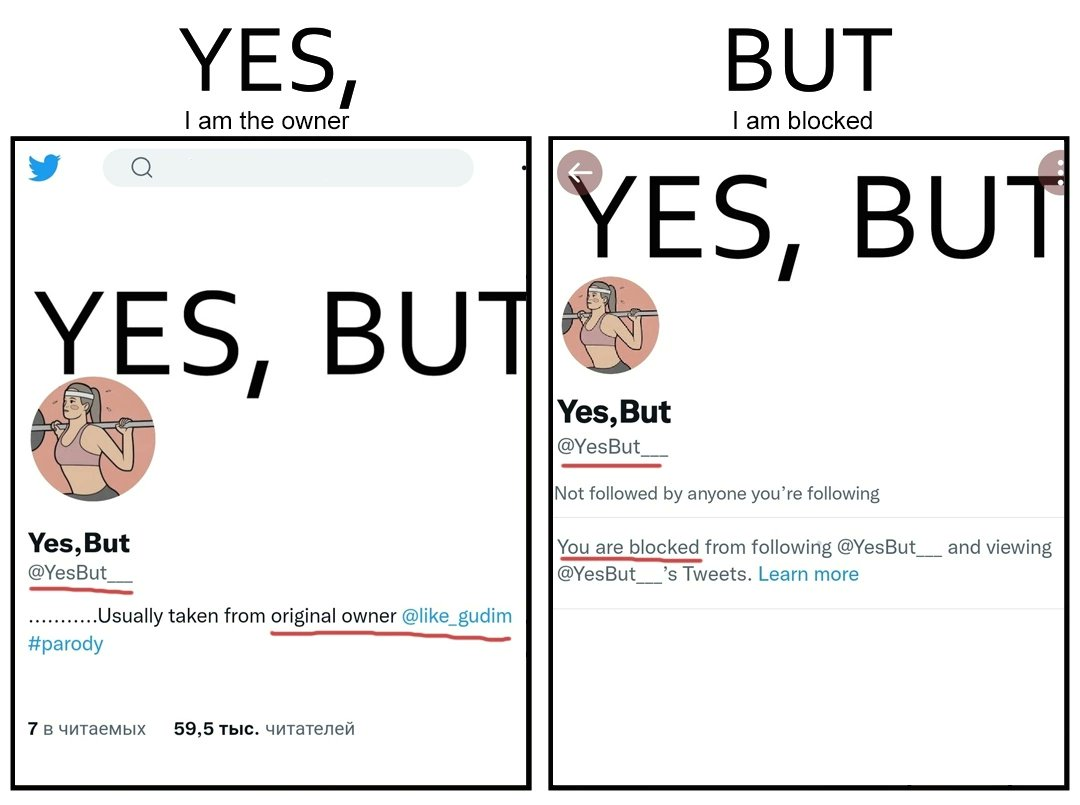Describe the contrast between the left and right parts of this image. In the left part of the image: It is a twitter account "Yes, But" that is crediting the actual owner "@like_gudim" for its posts In the right part of the image: Image showing user blocked from following the page "Yes, But" 